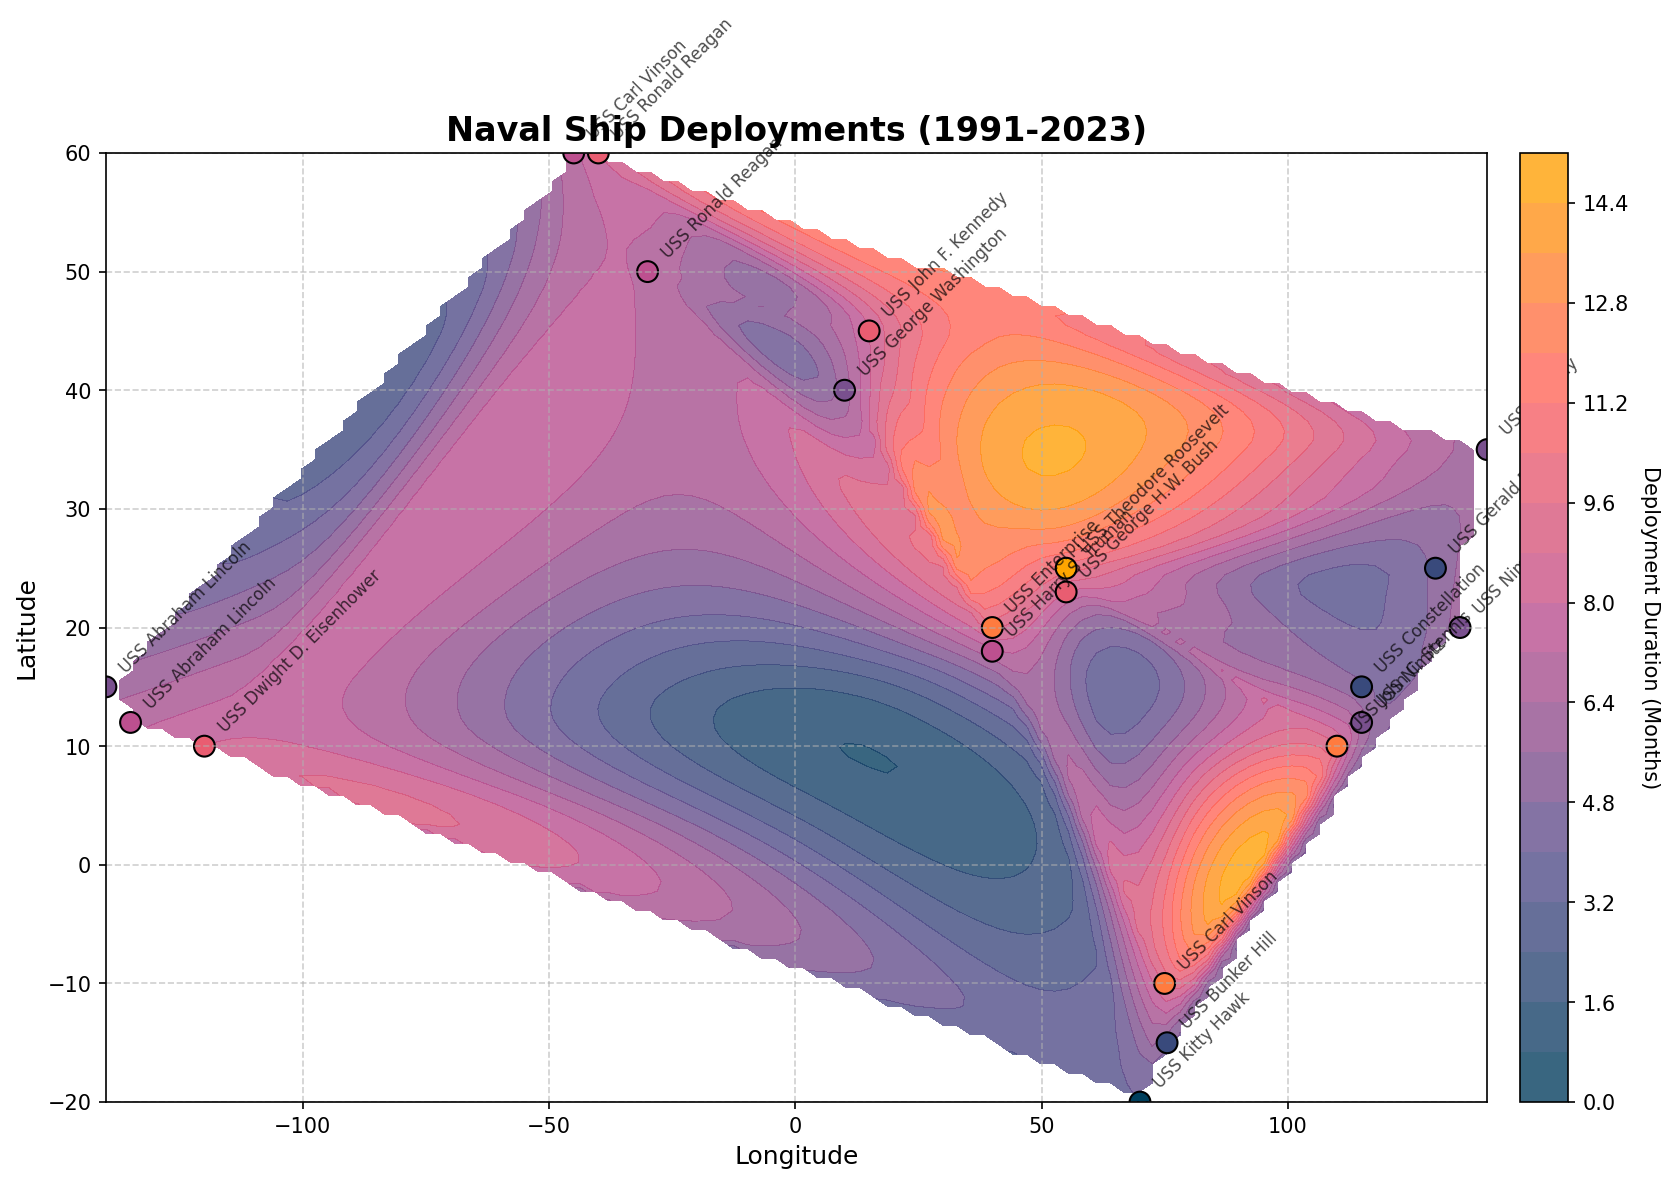What is the title of the figure? The title is usually located at the top of the figure and provides a concise summary of what the plot represents. In this case, it reads "Naval Ship Deployments (1991-2023)".
Answer: Naval Ship Deployments (1991-2023) What is the color range representing in the contour plot? The color range in the contour plot visually represents different deployment durations in months. Lighter colors generally indicate shorter durations, while darker colors indicate longer durations. This is reinforced by the colorbar's label which indicates that it represents "Deployment Duration (Months)".
Answer: Deployment duration in months Which ship has the longest deployment duration, and where is it located on the plot? First, look for the deployment durations (color gradient and the scatter plot colors). The USS Theodore Roosevelt in the Persian Gulf has the longest deployment duration of 10 months, indicated by the darkest color in the scale. It is plotted at coordinates (55.0, 25.0).
Answer: USS Theodore Roosevelt, Persian Gulf (55.0, 25.0) How many ships were deployed to the South China Sea? By observing the annotated ship names and their corresponding locations, you can see there are three ships: USS Constellation (1998), USS John C. Stennis (2010), and USS Nimitz (2022), all marked in the South China Sea region.
Answer: Three ships Which deployment area has the most ships, and how do you know? Looking at the annotations and their cluster density in specific regions, the Indian Ocean and South China Sea both contain three ships. You would count the number of points annotated in each area to determine this.
Answer: Indian Ocean and South China Sea (each with three ships) Compare the deployment durations between the USS Nimitz in 2003 and 2022. Which deployment was longer? Referring to the scatter plot where USS Nimitz is annotated, in 2003 (Western Pacific), its deployment duration was 6 months (color indicating duration). In 2022 (South China Sea), its deployment duration was also 6 months, thus, both deployments were of the same length.
Answer: Both were 6 months What are the longitude and latitude ranges covered in the plot? The ranges are determined by the x-axis (longitude) and y-axis (latitude). The longitude ranges approximately from -140 to 140 degrees, and the latitude ranges from about -20 to 60 degrees.
Answer: Longitude: -140 to 140, Latitude: -20 to 60 Considering the color gradient, what is the general trend in deployment durations relative to their longitude and latitude? By looking at the color intensities across the plot, it can be observed that the Western areas (e.g., Western Pacific and Eastern Pacific) tend to have shorter deployments (lighter colors), while areas like the Persian Gulf and Indian Ocean see darker shades indicating longer deployments.
Answer: Longer deployments are more frequent in central and east regions (e.g., Persian Gulf, Indian Ocean) Which ship had a deployment in the largest latitude range and what is it? The ship located at the most extreme northern latitude on the plot is the USS Midway, deployed in the Western Pacific at a latitude of 35.0 degrees.
Answer: USS Midway (35.0 degrees) Is there a deployment trend observable over time? By examining the annotations over years, there is no single clear time trend, as ships have been deployed in various durations and areas across the decades. The data points are scattered evenly through the years with varying durations and locations.
Answer: No single clear trend over time 